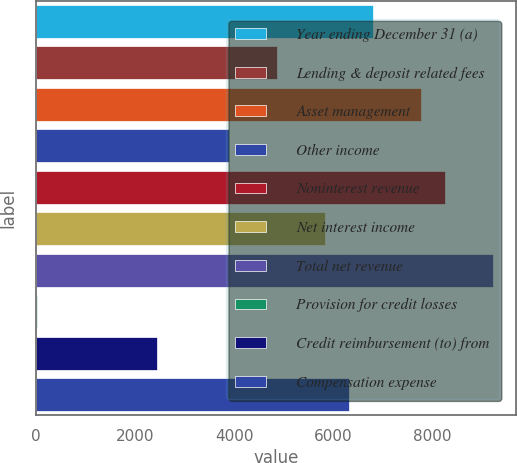<chart> <loc_0><loc_0><loc_500><loc_500><bar_chart><fcel>Year ending December 31 (a)<fcel>Lending & deposit related fees<fcel>Asset management<fcel>Other income<fcel>Noninterest revenue<fcel>Net interest income<fcel>Total net revenue<fcel>Provision for credit losses<fcel>Credit reimbursement (to) from<fcel>Compensation expense<nl><fcel>6797<fcel>4857<fcel>7767<fcel>3887<fcel>8252<fcel>5827<fcel>9222<fcel>7<fcel>2432<fcel>6312<nl></chart> 